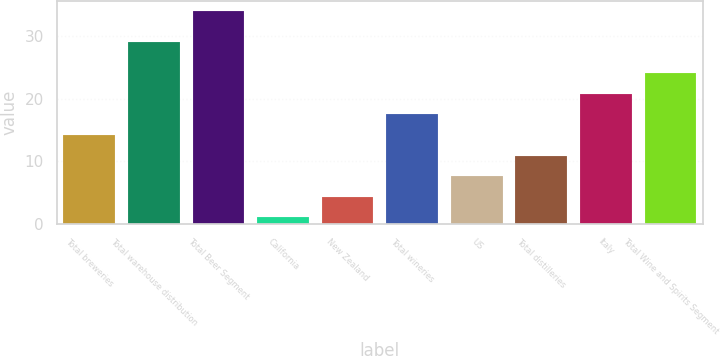Convert chart. <chart><loc_0><loc_0><loc_500><loc_500><bar_chart><fcel>Total breweries<fcel>Total warehouse distribution<fcel>Total Beer Segment<fcel>California<fcel>New Zealand<fcel>Total wineries<fcel>US<fcel>Total distilleries<fcel>Italy<fcel>Total Wine and Spirits Segment<nl><fcel>14.2<fcel>29<fcel>34<fcel>1<fcel>4.3<fcel>17.5<fcel>7.6<fcel>10.9<fcel>20.8<fcel>24.1<nl></chart> 